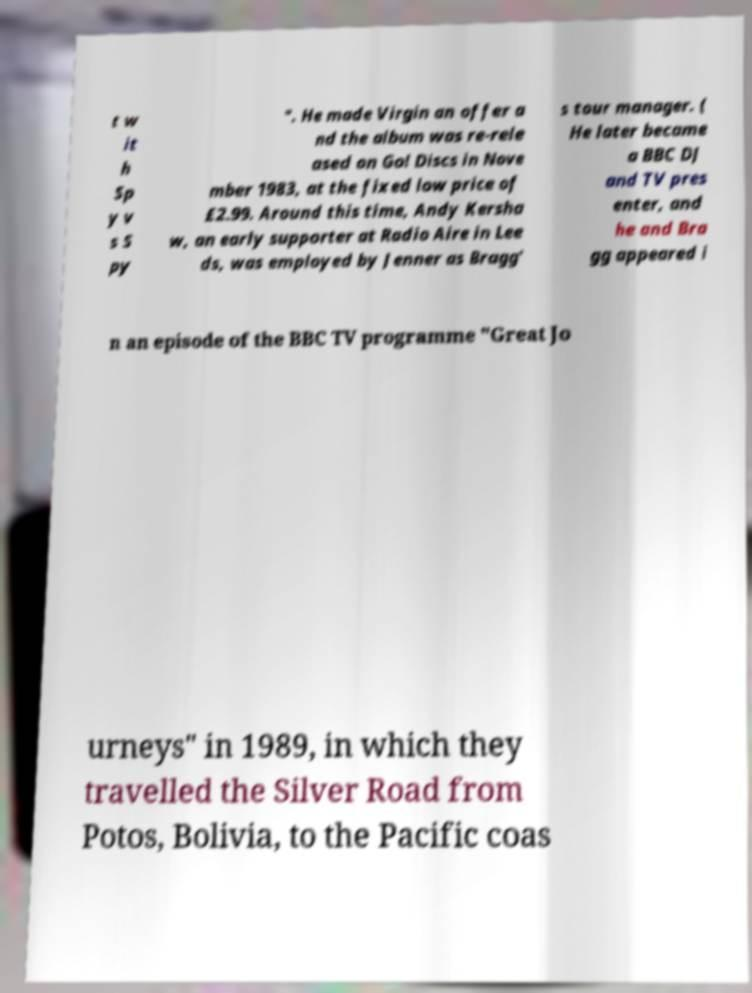Could you extract and type out the text from this image? t w it h Sp y v s S py ". He made Virgin an offer a nd the album was re-rele ased on Go! Discs in Nove mber 1983, at the fixed low price of £2.99. Around this time, Andy Kersha w, an early supporter at Radio Aire in Lee ds, was employed by Jenner as Bragg' s tour manager. ( He later became a BBC DJ and TV pres enter, and he and Bra gg appeared i n an episode of the BBC TV programme "Great Jo urneys" in 1989, in which they travelled the Silver Road from Potos, Bolivia, to the Pacific coas 